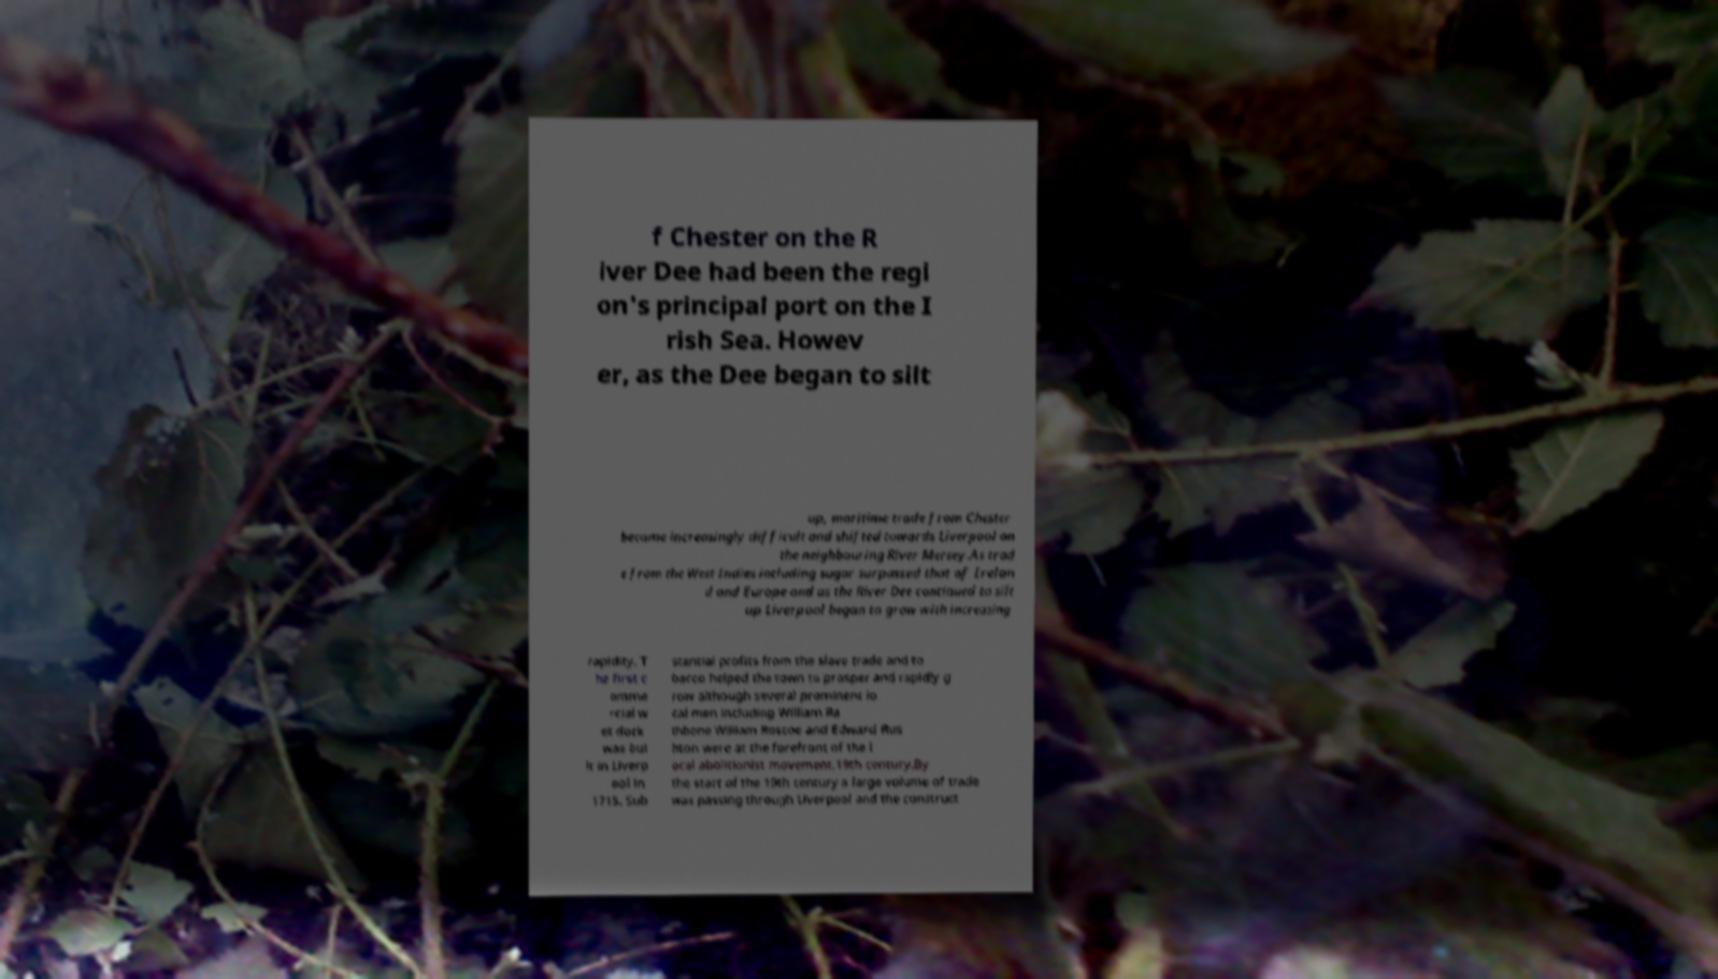Could you extract and type out the text from this image? f Chester on the R iver Dee had been the regi on's principal port on the I rish Sea. Howev er, as the Dee began to silt up, maritime trade from Chester became increasingly difficult and shifted towards Liverpool on the neighbouring River Mersey.As trad e from the West Indies including sugar surpassed that of Irelan d and Europe and as the River Dee continued to silt up Liverpool began to grow with increasing rapidity. T he first c omme rcial w et dock was bui lt in Liverp ool in 1715. Sub stantial profits from the slave trade and to bacco helped the town to prosper and rapidly g row although several prominent lo cal men including William Ra thbone William Roscoe and Edward Rus hton were at the forefront of the l ocal abolitionist movement.19th century.By the start of the 19th century a large volume of trade was passing through Liverpool and the construct 